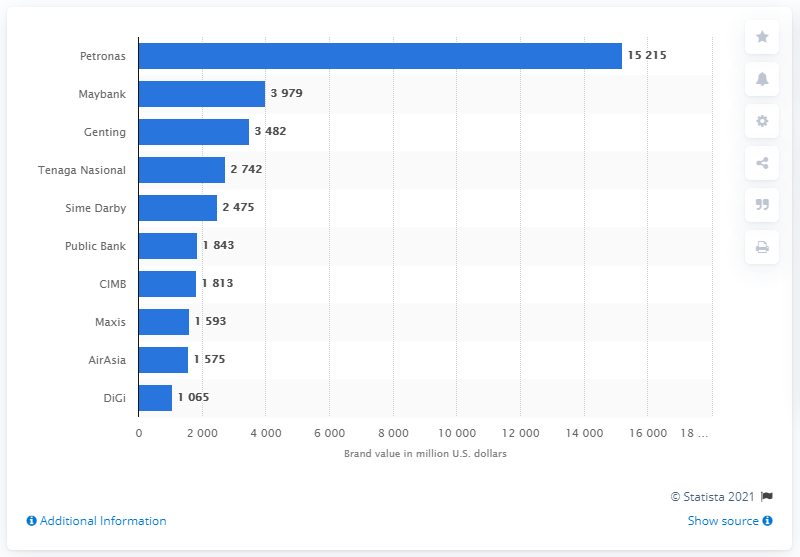Can you tell me more about the trend among the lesser-valued brands? Certainly, looking at the image, as we move down the list of Malaysian brands, there's a noticeable trend of decreasing brand value. For instance, brands like Maxis and AirAsia have brand values in the mid-1 billion U.S. dollars, while Digi is slightly over one billion. It suggests that the market dominance in terms of brand value is not evenly distributed, but rather concentrated at the top with a steep fall off as you go down the list. 